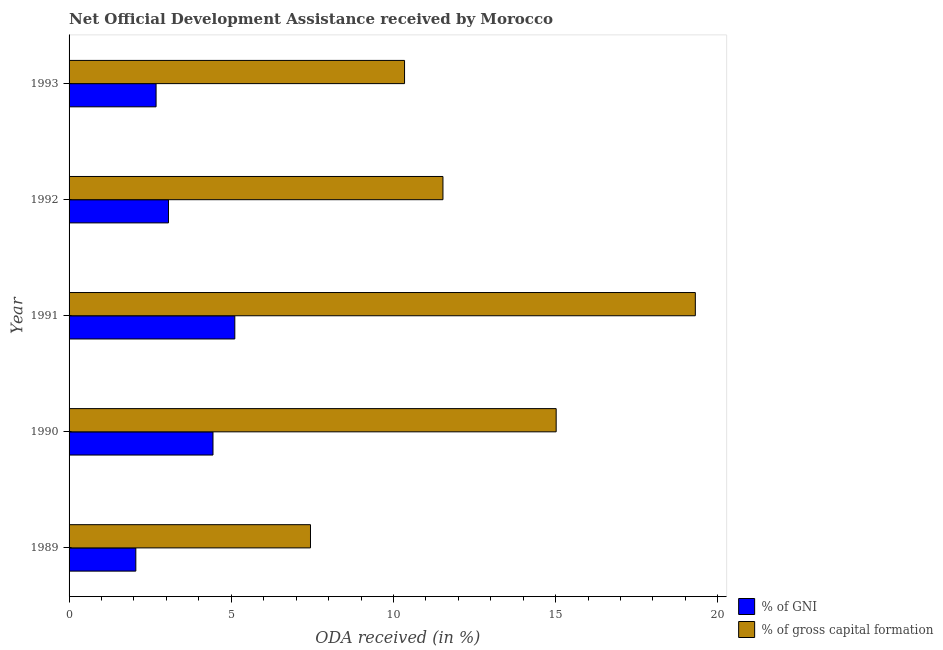How many groups of bars are there?
Ensure brevity in your answer.  5. Are the number of bars per tick equal to the number of legend labels?
Provide a short and direct response. Yes. Are the number of bars on each tick of the Y-axis equal?
Your answer should be compact. Yes. In how many cases, is the number of bars for a given year not equal to the number of legend labels?
Keep it short and to the point. 0. What is the oda received as percentage of gross capital formation in 1991?
Your answer should be compact. 19.31. Across all years, what is the maximum oda received as percentage of gross capital formation?
Provide a succinct answer. 19.31. Across all years, what is the minimum oda received as percentage of gni?
Provide a short and direct response. 2.06. In which year was the oda received as percentage of gni minimum?
Offer a very short reply. 1989. What is the total oda received as percentage of gross capital formation in the graph?
Provide a succinct answer. 63.63. What is the difference between the oda received as percentage of gni in 1990 and that in 1992?
Your answer should be very brief. 1.37. What is the difference between the oda received as percentage of gni in 1989 and the oda received as percentage of gross capital formation in 1990?
Provide a short and direct response. -12.96. What is the average oda received as percentage of gni per year?
Your answer should be very brief. 3.47. In the year 1990, what is the difference between the oda received as percentage of gross capital formation and oda received as percentage of gni?
Provide a succinct answer. 10.58. In how many years, is the oda received as percentage of gross capital formation greater than 16 %?
Your answer should be compact. 1. What is the ratio of the oda received as percentage of gross capital formation in 1989 to that in 1990?
Your answer should be very brief. 0.5. Is the oda received as percentage of gross capital formation in 1991 less than that in 1992?
Offer a very short reply. No. What is the difference between the highest and the second highest oda received as percentage of gross capital formation?
Provide a succinct answer. 4.29. What is the difference between the highest and the lowest oda received as percentage of gross capital formation?
Offer a terse response. 11.86. What does the 1st bar from the top in 1990 represents?
Make the answer very short. % of gross capital formation. What does the 2nd bar from the bottom in 1990 represents?
Give a very brief answer. % of gross capital formation. How many years are there in the graph?
Provide a short and direct response. 5. What is the difference between two consecutive major ticks on the X-axis?
Provide a short and direct response. 5. Are the values on the major ticks of X-axis written in scientific E-notation?
Make the answer very short. No. Does the graph contain any zero values?
Offer a terse response. No. Where does the legend appear in the graph?
Ensure brevity in your answer.  Bottom right. How are the legend labels stacked?
Provide a succinct answer. Vertical. What is the title of the graph?
Provide a short and direct response. Net Official Development Assistance received by Morocco. Does "Goods" appear as one of the legend labels in the graph?
Keep it short and to the point. No. What is the label or title of the X-axis?
Offer a very short reply. ODA received (in %). What is the label or title of the Y-axis?
Offer a very short reply. Year. What is the ODA received (in %) in % of GNI in 1989?
Give a very brief answer. 2.06. What is the ODA received (in %) in % of gross capital formation in 1989?
Provide a succinct answer. 7.44. What is the ODA received (in %) of % of GNI in 1990?
Ensure brevity in your answer.  4.44. What is the ODA received (in %) of % of gross capital formation in 1990?
Keep it short and to the point. 15.02. What is the ODA received (in %) of % of GNI in 1991?
Your answer should be very brief. 5.11. What is the ODA received (in %) in % of gross capital formation in 1991?
Keep it short and to the point. 19.31. What is the ODA received (in %) in % of GNI in 1992?
Your answer should be compact. 3.06. What is the ODA received (in %) of % of gross capital formation in 1992?
Ensure brevity in your answer.  11.53. What is the ODA received (in %) of % of GNI in 1993?
Offer a terse response. 2.68. What is the ODA received (in %) in % of gross capital formation in 1993?
Give a very brief answer. 10.34. Across all years, what is the maximum ODA received (in %) in % of GNI?
Provide a succinct answer. 5.11. Across all years, what is the maximum ODA received (in %) in % of gross capital formation?
Ensure brevity in your answer.  19.31. Across all years, what is the minimum ODA received (in %) of % of GNI?
Keep it short and to the point. 2.06. Across all years, what is the minimum ODA received (in %) of % of gross capital formation?
Your response must be concise. 7.44. What is the total ODA received (in %) in % of GNI in the graph?
Give a very brief answer. 17.35. What is the total ODA received (in %) of % of gross capital formation in the graph?
Your answer should be very brief. 63.63. What is the difference between the ODA received (in %) of % of GNI in 1989 and that in 1990?
Ensure brevity in your answer.  -2.38. What is the difference between the ODA received (in %) in % of gross capital formation in 1989 and that in 1990?
Provide a succinct answer. -7.57. What is the difference between the ODA received (in %) of % of GNI in 1989 and that in 1991?
Your answer should be compact. -3.05. What is the difference between the ODA received (in %) in % of gross capital formation in 1989 and that in 1991?
Your response must be concise. -11.86. What is the difference between the ODA received (in %) of % of GNI in 1989 and that in 1992?
Keep it short and to the point. -1.01. What is the difference between the ODA received (in %) of % of gross capital formation in 1989 and that in 1992?
Ensure brevity in your answer.  -4.08. What is the difference between the ODA received (in %) of % of GNI in 1989 and that in 1993?
Ensure brevity in your answer.  -0.62. What is the difference between the ODA received (in %) of % of gross capital formation in 1989 and that in 1993?
Your answer should be very brief. -2.9. What is the difference between the ODA received (in %) in % of GNI in 1990 and that in 1991?
Keep it short and to the point. -0.67. What is the difference between the ODA received (in %) in % of gross capital formation in 1990 and that in 1991?
Your response must be concise. -4.29. What is the difference between the ODA received (in %) of % of GNI in 1990 and that in 1992?
Your answer should be compact. 1.37. What is the difference between the ODA received (in %) in % of gross capital formation in 1990 and that in 1992?
Your response must be concise. 3.49. What is the difference between the ODA received (in %) in % of GNI in 1990 and that in 1993?
Your answer should be compact. 1.75. What is the difference between the ODA received (in %) of % of gross capital formation in 1990 and that in 1993?
Make the answer very short. 4.67. What is the difference between the ODA received (in %) in % of GNI in 1991 and that in 1992?
Make the answer very short. 2.04. What is the difference between the ODA received (in %) of % of gross capital formation in 1991 and that in 1992?
Your response must be concise. 7.78. What is the difference between the ODA received (in %) of % of GNI in 1991 and that in 1993?
Your answer should be compact. 2.43. What is the difference between the ODA received (in %) of % of gross capital formation in 1991 and that in 1993?
Your answer should be very brief. 8.96. What is the difference between the ODA received (in %) of % of GNI in 1992 and that in 1993?
Offer a very short reply. 0.38. What is the difference between the ODA received (in %) in % of gross capital formation in 1992 and that in 1993?
Offer a very short reply. 1.18. What is the difference between the ODA received (in %) in % of GNI in 1989 and the ODA received (in %) in % of gross capital formation in 1990?
Make the answer very short. -12.96. What is the difference between the ODA received (in %) of % of GNI in 1989 and the ODA received (in %) of % of gross capital formation in 1991?
Offer a very short reply. -17.25. What is the difference between the ODA received (in %) of % of GNI in 1989 and the ODA received (in %) of % of gross capital formation in 1992?
Offer a very short reply. -9.47. What is the difference between the ODA received (in %) in % of GNI in 1989 and the ODA received (in %) in % of gross capital formation in 1993?
Your answer should be very brief. -8.28. What is the difference between the ODA received (in %) of % of GNI in 1990 and the ODA received (in %) of % of gross capital formation in 1991?
Offer a terse response. -14.87. What is the difference between the ODA received (in %) in % of GNI in 1990 and the ODA received (in %) in % of gross capital formation in 1992?
Your answer should be compact. -7.09. What is the difference between the ODA received (in %) of % of GNI in 1990 and the ODA received (in %) of % of gross capital formation in 1993?
Offer a very short reply. -5.91. What is the difference between the ODA received (in %) of % of GNI in 1991 and the ODA received (in %) of % of gross capital formation in 1992?
Offer a terse response. -6.42. What is the difference between the ODA received (in %) of % of GNI in 1991 and the ODA received (in %) of % of gross capital formation in 1993?
Ensure brevity in your answer.  -5.23. What is the difference between the ODA received (in %) in % of GNI in 1992 and the ODA received (in %) in % of gross capital formation in 1993?
Keep it short and to the point. -7.28. What is the average ODA received (in %) in % of GNI per year?
Give a very brief answer. 3.47. What is the average ODA received (in %) of % of gross capital formation per year?
Provide a short and direct response. 12.73. In the year 1989, what is the difference between the ODA received (in %) in % of GNI and ODA received (in %) in % of gross capital formation?
Your answer should be compact. -5.38. In the year 1990, what is the difference between the ODA received (in %) in % of GNI and ODA received (in %) in % of gross capital formation?
Your answer should be very brief. -10.58. In the year 1991, what is the difference between the ODA received (in %) of % of GNI and ODA received (in %) of % of gross capital formation?
Keep it short and to the point. -14.2. In the year 1992, what is the difference between the ODA received (in %) of % of GNI and ODA received (in %) of % of gross capital formation?
Provide a succinct answer. -8.46. In the year 1993, what is the difference between the ODA received (in %) of % of GNI and ODA received (in %) of % of gross capital formation?
Make the answer very short. -7.66. What is the ratio of the ODA received (in %) of % of GNI in 1989 to that in 1990?
Ensure brevity in your answer.  0.46. What is the ratio of the ODA received (in %) in % of gross capital formation in 1989 to that in 1990?
Provide a short and direct response. 0.5. What is the ratio of the ODA received (in %) of % of GNI in 1989 to that in 1991?
Make the answer very short. 0.4. What is the ratio of the ODA received (in %) of % of gross capital formation in 1989 to that in 1991?
Provide a succinct answer. 0.39. What is the ratio of the ODA received (in %) in % of GNI in 1989 to that in 1992?
Provide a short and direct response. 0.67. What is the ratio of the ODA received (in %) of % of gross capital formation in 1989 to that in 1992?
Offer a very short reply. 0.65. What is the ratio of the ODA received (in %) in % of GNI in 1989 to that in 1993?
Your answer should be compact. 0.77. What is the ratio of the ODA received (in %) of % of gross capital formation in 1989 to that in 1993?
Make the answer very short. 0.72. What is the ratio of the ODA received (in %) in % of GNI in 1990 to that in 1991?
Give a very brief answer. 0.87. What is the ratio of the ODA received (in %) in % of GNI in 1990 to that in 1992?
Your response must be concise. 1.45. What is the ratio of the ODA received (in %) of % of gross capital formation in 1990 to that in 1992?
Ensure brevity in your answer.  1.3. What is the ratio of the ODA received (in %) in % of GNI in 1990 to that in 1993?
Your response must be concise. 1.65. What is the ratio of the ODA received (in %) of % of gross capital formation in 1990 to that in 1993?
Give a very brief answer. 1.45. What is the ratio of the ODA received (in %) of % of GNI in 1991 to that in 1992?
Make the answer very short. 1.67. What is the ratio of the ODA received (in %) in % of gross capital formation in 1991 to that in 1992?
Your answer should be compact. 1.68. What is the ratio of the ODA received (in %) in % of GNI in 1991 to that in 1993?
Make the answer very short. 1.9. What is the ratio of the ODA received (in %) in % of gross capital formation in 1991 to that in 1993?
Offer a terse response. 1.87. What is the ratio of the ODA received (in %) of % of GNI in 1992 to that in 1993?
Ensure brevity in your answer.  1.14. What is the ratio of the ODA received (in %) in % of gross capital formation in 1992 to that in 1993?
Provide a succinct answer. 1.11. What is the difference between the highest and the second highest ODA received (in %) in % of GNI?
Your answer should be very brief. 0.67. What is the difference between the highest and the second highest ODA received (in %) of % of gross capital formation?
Keep it short and to the point. 4.29. What is the difference between the highest and the lowest ODA received (in %) in % of GNI?
Provide a short and direct response. 3.05. What is the difference between the highest and the lowest ODA received (in %) of % of gross capital formation?
Ensure brevity in your answer.  11.86. 